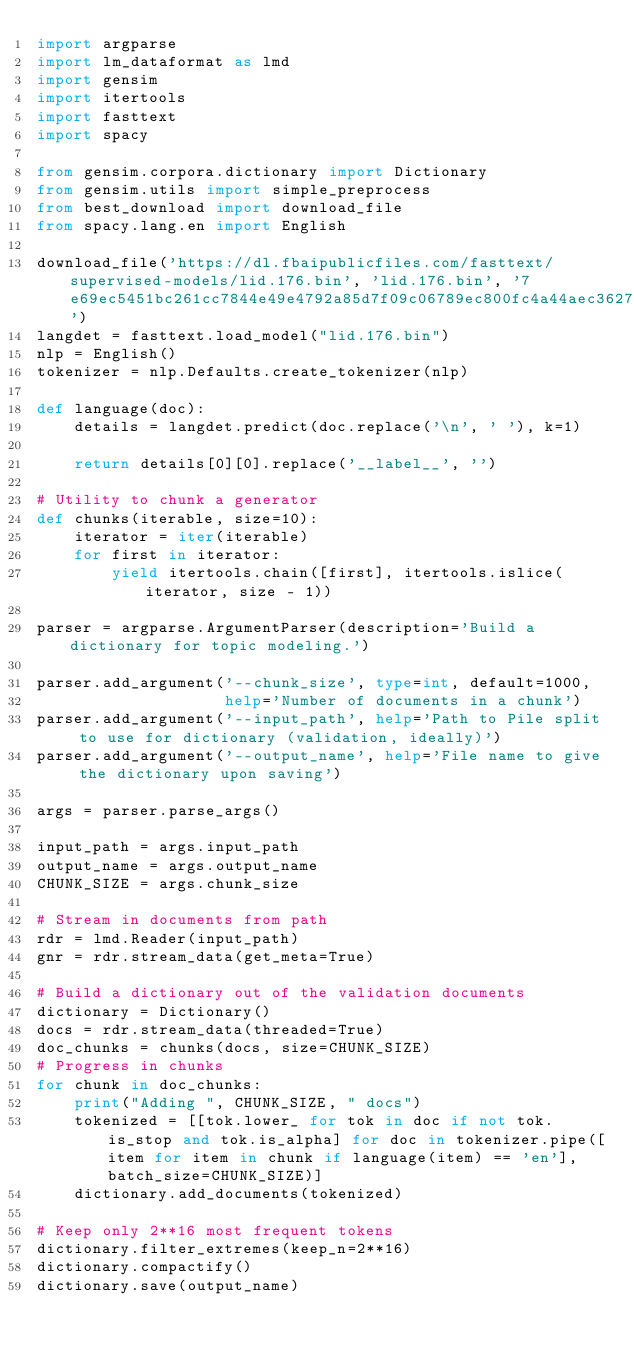Convert code to text. <code><loc_0><loc_0><loc_500><loc_500><_Python_>import argparse
import lm_dataformat as lmd
import gensim
import itertools
import fasttext
import spacy

from gensim.corpora.dictionary import Dictionary
from gensim.utils import simple_preprocess
from best_download import download_file
from spacy.lang.en import English

download_file('https://dl.fbaipublicfiles.com/fasttext/supervised-models/lid.176.bin', 'lid.176.bin', '7e69ec5451bc261cc7844e49e4792a85d7f09c06789ec800fc4a44aec362764e')
langdet = fasttext.load_model("lid.176.bin")
nlp = English()
tokenizer = nlp.Defaults.create_tokenizer(nlp)

def language(doc):
    details = langdet.predict(doc.replace('\n', ' '), k=1)

    return details[0][0].replace('__label__', '')

# Utility to chunk a generator
def chunks(iterable, size=10):
    iterator = iter(iterable)
    for first in iterator:
        yield itertools.chain([first], itertools.islice(iterator, size - 1))

parser = argparse.ArgumentParser(description='Build a dictionary for topic modeling.')

parser.add_argument('--chunk_size', type=int, default=1000,
                    help='Number of documents in a chunk')
parser.add_argument('--input_path', help='Path to Pile split to use for dictionary (validation, ideally)')
parser.add_argument('--output_name', help='File name to give the dictionary upon saving')

args = parser.parse_args()

input_path = args.input_path
output_name = args.output_name
CHUNK_SIZE = args.chunk_size

# Stream in documents from path
rdr = lmd.Reader(input_path)
gnr = rdr.stream_data(get_meta=True)

# Build a dictionary out of the validation documents
dictionary = Dictionary()
docs = rdr.stream_data(threaded=True)
doc_chunks = chunks(docs, size=CHUNK_SIZE)
# Progress in chunks
for chunk in doc_chunks:
    print("Adding ", CHUNK_SIZE, " docs")
    tokenized = [[tok.lower_ for tok in doc if not tok.is_stop and tok.is_alpha] for doc in tokenizer.pipe([item for item in chunk if language(item) == 'en'], batch_size=CHUNK_SIZE)]
    dictionary.add_documents(tokenized)

# Keep only 2**16 most frequent tokens
dictionary.filter_extremes(keep_n=2**16)
dictionary.compactify()
dictionary.save(output_name)
</code> 